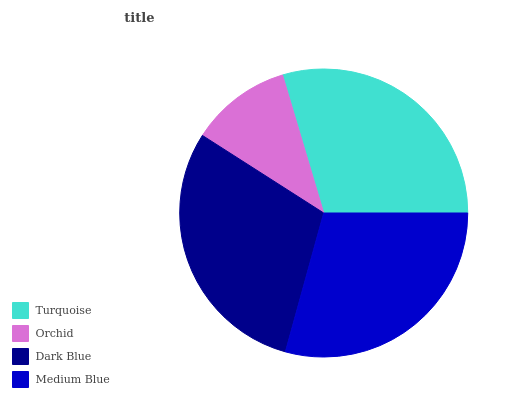Is Orchid the minimum?
Answer yes or no. Yes. Is Dark Blue the maximum?
Answer yes or no. Yes. Is Dark Blue the minimum?
Answer yes or no. No. Is Orchid the maximum?
Answer yes or no. No. Is Dark Blue greater than Orchid?
Answer yes or no. Yes. Is Orchid less than Dark Blue?
Answer yes or no. Yes. Is Orchid greater than Dark Blue?
Answer yes or no. No. Is Dark Blue less than Orchid?
Answer yes or no. No. Is Turquoise the high median?
Answer yes or no. Yes. Is Medium Blue the low median?
Answer yes or no. Yes. Is Medium Blue the high median?
Answer yes or no. No. Is Dark Blue the low median?
Answer yes or no. No. 